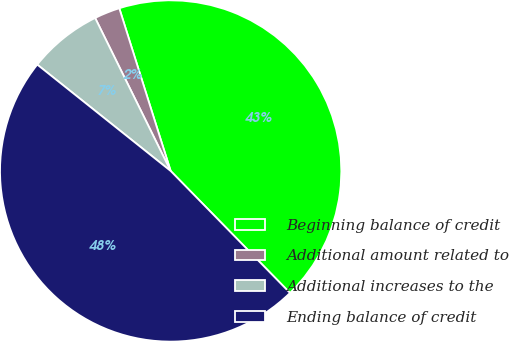<chart> <loc_0><loc_0><loc_500><loc_500><pie_chart><fcel>Beginning balance of credit<fcel>Additional amount related to<fcel>Additional increases to the<fcel>Ending balance of credit<nl><fcel>42.54%<fcel>2.43%<fcel>6.99%<fcel>48.04%<nl></chart> 